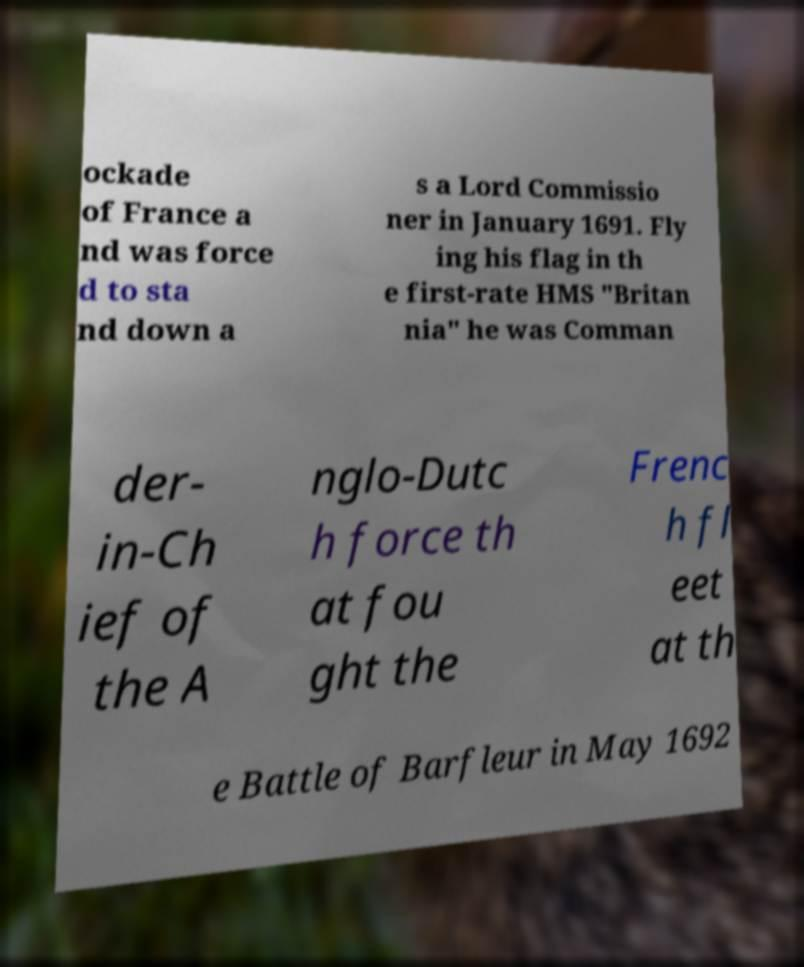Please read and relay the text visible in this image. What does it say? ockade of France a nd was force d to sta nd down a s a Lord Commissio ner in January 1691. Fly ing his flag in th e first-rate HMS "Britan nia" he was Comman der- in-Ch ief of the A nglo-Dutc h force th at fou ght the Frenc h fl eet at th e Battle of Barfleur in May 1692 